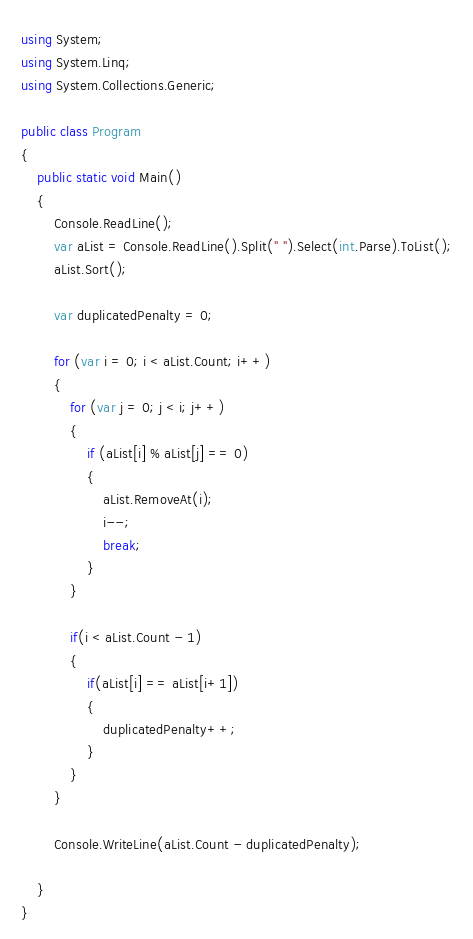Convert code to text. <code><loc_0><loc_0><loc_500><loc_500><_C#_>using System;
using System.Linq;
using System.Collections.Generic;

public class Program
{
    public static void Main()
    {
        Console.ReadLine();
        var aList = Console.ReadLine().Split(" ").Select(int.Parse).ToList();
        aList.Sort();

        var duplicatedPenalty = 0;

        for (var i = 0; i < aList.Count; i++)
        {
            for (var j = 0; j < i; j++)
            {
                if (aList[i] % aList[j] == 0)
                {
                    aList.RemoveAt(i);
                    i--;
                    break;
                }
            }

            if(i < aList.Count - 1)
            {
                if(aList[i] == aList[i+1])
                {
                    duplicatedPenalty++;
                }
            }
        }

        Console.WriteLine(aList.Count - duplicatedPenalty);

    }
}</code> 